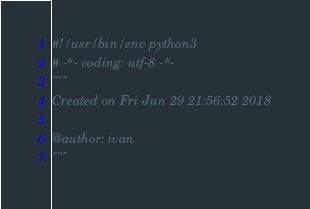<code> <loc_0><loc_0><loc_500><loc_500><_Python_>#!/usr/bin/env python3
# -*- coding: utf-8 -*-
"""
Created on Fri Jun 29 21:56:52 2018

@author: ivan
"""

</code> 